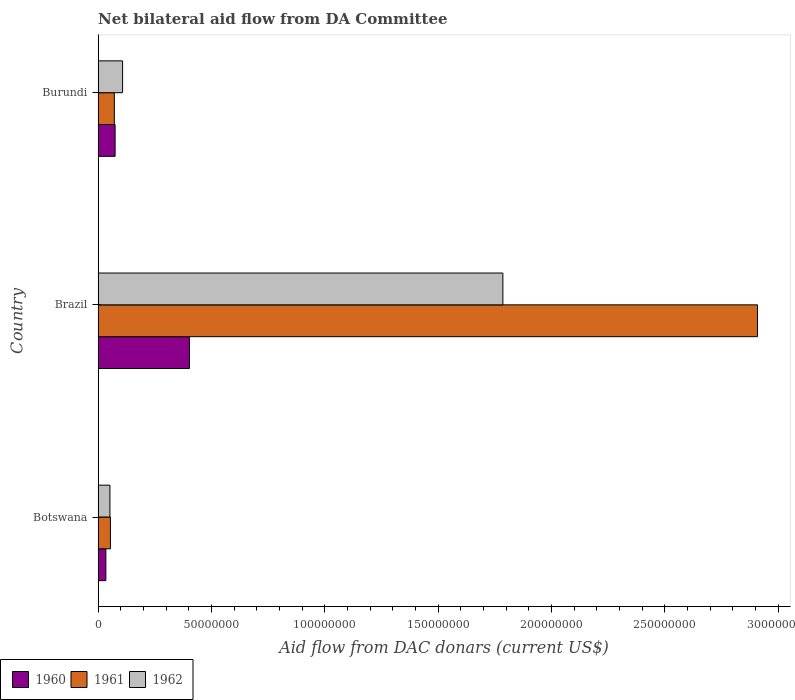Are the number of bars per tick equal to the number of legend labels?
Offer a very short reply. Yes. What is the label of the 3rd group of bars from the top?
Your answer should be very brief. Botswana. What is the aid flow in in 1962 in Burundi?
Keep it short and to the point. 1.08e+07. Across all countries, what is the maximum aid flow in in 1962?
Your answer should be very brief. 1.79e+08. Across all countries, what is the minimum aid flow in in 1961?
Keep it short and to the point. 5.44e+06. In which country was the aid flow in in 1962 minimum?
Offer a very short reply. Botswana. What is the total aid flow in in 1960 in the graph?
Offer a terse response. 5.12e+07. What is the difference between the aid flow in in 1961 in Botswana and that in Brazil?
Offer a terse response. -2.85e+08. What is the difference between the aid flow in in 1961 in Brazil and the aid flow in in 1960 in Botswana?
Give a very brief answer. 2.87e+08. What is the average aid flow in in 1962 per country?
Provide a succinct answer. 6.49e+07. What is the difference between the aid flow in in 1961 and aid flow in in 1962 in Brazil?
Ensure brevity in your answer.  1.12e+08. In how many countries, is the aid flow in in 1961 greater than 280000000 US$?
Your answer should be compact. 1. What is the ratio of the aid flow in in 1960 in Botswana to that in Burundi?
Offer a very short reply. 0.46. Is the difference between the aid flow in in 1961 in Botswana and Burundi greater than the difference between the aid flow in in 1962 in Botswana and Burundi?
Make the answer very short. Yes. What is the difference between the highest and the second highest aid flow in in 1960?
Keep it short and to the point. 3.28e+07. What is the difference between the highest and the lowest aid flow in in 1961?
Your answer should be compact. 2.85e+08. Is the sum of the aid flow in in 1961 in Botswana and Burundi greater than the maximum aid flow in in 1962 across all countries?
Offer a very short reply. No. What does the 1st bar from the top in Brazil represents?
Offer a terse response. 1962. How many countries are there in the graph?
Provide a succinct answer. 3. Does the graph contain any zero values?
Provide a succinct answer. No. What is the title of the graph?
Ensure brevity in your answer.  Net bilateral aid flow from DA Committee. Does "2002" appear as one of the legend labels in the graph?
Ensure brevity in your answer.  No. What is the label or title of the X-axis?
Your response must be concise. Aid flow from DAC donars (current US$). What is the Aid flow from DAC donars (current US$) in 1960 in Botswana?
Ensure brevity in your answer.  3.43e+06. What is the Aid flow from DAC donars (current US$) of 1961 in Botswana?
Your response must be concise. 5.44e+06. What is the Aid flow from DAC donars (current US$) of 1962 in Botswana?
Keep it short and to the point. 5.23e+06. What is the Aid flow from DAC donars (current US$) of 1960 in Brazil?
Provide a succinct answer. 4.03e+07. What is the Aid flow from DAC donars (current US$) in 1961 in Brazil?
Your answer should be very brief. 2.91e+08. What is the Aid flow from DAC donars (current US$) of 1962 in Brazil?
Your answer should be compact. 1.79e+08. What is the Aid flow from DAC donars (current US$) in 1960 in Burundi?
Offer a terse response. 7.51e+06. What is the Aid flow from DAC donars (current US$) in 1961 in Burundi?
Ensure brevity in your answer.  7.17e+06. What is the Aid flow from DAC donars (current US$) in 1962 in Burundi?
Your answer should be very brief. 1.08e+07. Across all countries, what is the maximum Aid flow from DAC donars (current US$) in 1960?
Give a very brief answer. 4.03e+07. Across all countries, what is the maximum Aid flow from DAC donars (current US$) in 1961?
Make the answer very short. 2.91e+08. Across all countries, what is the maximum Aid flow from DAC donars (current US$) of 1962?
Ensure brevity in your answer.  1.79e+08. Across all countries, what is the minimum Aid flow from DAC donars (current US$) of 1960?
Ensure brevity in your answer.  3.43e+06. Across all countries, what is the minimum Aid flow from DAC donars (current US$) in 1961?
Offer a very short reply. 5.44e+06. Across all countries, what is the minimum Aid flow from DAC donars (current US$) of 1962?
Offer a very short reply. 5.23e+06. What is the total Aid flow from DAC donars (current US$) in 1960 in the graph?
Your answer should be compact. 5.12e+07. What is the total Aid flow from DAC donars (current US$) in 1961 in the graph?
Offer a very short reply. 3.04e+08. What is the total Aid flow from DAC donars (current US$) of 1962 in the graph?
Keep it short and to the point. 1.95e+08. What is the difference between the Aid flow from DAC donars (current US$) of 1960 in Botswana and that in Brazil?
Offer a very short reply. -3.69e+07. What is the difference between the Aid flow from DAC donars (current US$) of 1961 in Botswana and that in Brazil?
Give a very brief answer. -2.85e+08. What is the difference between the Aid flow from DAC donars (current US$) in 1962 in Botswana and that in Brazil?
Your response must be concise. -1.73e+08. What is the difference between the Aid flow from DAC donars (current US$) in 1960 in Botswana and that in Burundi?
Offer a very short reply. -4.08e+06. What is the difference between the Aid flow from DAC donars (current US$) of 1961 in Botswana and that in Burundi?
Ensure brevity in your answer.  -1.73e+06. What is the difference between the Aid flow from DAC donars (current US$) of 1962 in Botswana and that in Burundi?
Offer a very short reply. -5.58e+06. What is the difference between the Aid flow from DAC donars (current US$) of 1960 in Brazil and that in Burundi?
Your answer should be compact. 3.28e+07. What is the difference between the Aid flow from DAC donars (current US$) of 1961 in Brazil and that in Burundi?
Your answer should be compact. 2.84e+08. What is the difference between the Aid flow from DAC donars (current US$) in 1962 in Brazil and that in Burundi?
Provide a succinct answer. 1.68e+08. What is the difference between the Aid flow from DAC donars (current US$) in 1960 in Botswana and the Aid flow from DAC donars (current US$) in 1961 in Brazil?
Ensure brevity in your answer.  -2.87e+08. What is the difference between the Aid flow from DAC donars (current US$) in 1960 in Botswana and the Aid flow from DAC donars (current US$) in 1962 in Brazil?
Your answer should be very brief. -1.75e+08. What is the difference between the Aid flow from DAC donars (current US$) in 1961 in Botswana and the Aid flow from DAC donars (current US$) in 1962 in Brazil?
Give a very brief answer. -1.73e+08. What is the difference between the Aid flow from DAC donars (current US$) in 1960 in Botswana and the Aid flow from DAC donars (current US$) in 1961 in Burundi?
Keep it short and to the point. -3.74e+06. What is the difference between the Aid flow from DAC donars (current US$) in 1960 in Botswana and the Aid flow from DAC donars (current US$) in 1962 in Burundi?
Offer a very short reply. -7.38e+06. What is the difference between the Aid flow from DAC donars (current US$) of 1961 in Botswana and the Aid flow from DAC donars (current US$) of 1962 in Burundi?
Offer a terse response. -5.37e+06. What is the difference between the Aid flow from DAC donars (current US$) of 1960 in Brazil and the Aid flow from DAC donars (current US$) of 1961 in Burundi?
Give a very brief answer. 3.31e+07. What is the difference between the Aid flow from DAC donars (current US$) of 1960 in Brazil and the Aid flow from DAC donars (current US$) of 1962 in Burundi?
Your answer should be compact. 2.95e+07. What is the difference between the Aid flow from DAC donars (current US$) of 1961 in Brazil and the Aid flow from DAC donars (current US$) of 1962 in Burundi?
Your answer should be very brief. 2.80e+08. What is the average Aid flow from DAC donars (current US$) in 1960 per country?
Provide a succinct answer. 1.71e+07. What is the average Aid flow from DAC donars (current US$) in 1961 per country?
Provide a succinct answer. 1.01e+08. What is the average Aid flow from DAC donars (current US$) in 1962 per country?
Provide a short and direct response. 6.49e+07. What is the difference between the Aid flow from DAC donars (current US$) of 1960 and Aid flow from DAC donars (current US$) of 1961 in Botswana?
Your answer should be compact. -2.01e+06. What is the difference between the Aid flow from DAC donars (current US$) of 1960 and Aid flow from DAC donars (current US$) of 1962 in Botswana?
Offer a very short reply. -1.80e+06. What is the difference between the Aid flow from DAC donars (current US$) in 1960 and Aid flow from DAC donars (current US$) in 1961 in Brazil?
Keep it short and to the point. -2.51e+08. What is the difference between the Aid flow from DAC donars (current US$) of 1960 and Aid flow from DAC donars (current US$) of 1962 in Brazil?
Ensure brevity in your answer.  -1.38e+08. What is the difference between the Aid flow from DAC donars (current US$) of 1961 and Aid flow from DAC donars (current US$) of 1962 in Brazil?
Provide a short and direct response. 1.12e+08. What is the difference between the Aid flow from DAC donars (current US$) in 1960 and Aid flow from DAC donars (current US$) in 1961 in Burundi?
Give a very brief answer. 3.40e+05. What is the difference between the Aid flow from DAC donars (current US$) in 1960 and Aid flow from DAC donars (current US$) in 1962 in Burundi?
Give a very brief answer. -3.30e+06. What is the difference between the Aid flow from DAC donars (current US$) in 1961 and Aid flow from DAC donars (current US$) in 1962 in Burundi?
Give a very brief answer. -3.64e+06. What is the ratio of the Aid flow from DAC donars (current US$) of 1960 in Botswana to that in Brazil?
Provide a short and direct response. 0.09. What is the ratio of the Aid flow from DAC donars (current US$) of 1961 in Botswana to that in Brazil?
Make the answer very short. 0.02. What is the ratio of the Aid flow from DAC donars (current US$) of 1962 in Botswana to that in Brazil?
Your answer should be very brief. 0.03. What is the ratio of the Aid flow from DAC donars (current US$) of 1960 in Botswana to that in Burundi?
Give a very brief answer. 0.46. What is the ratio of the Aid flow from DAC donars (current US$) of 1961 in Botswana to that in Burundi?
Provide a succinct answer. 0.76. What is the ratio of the Aid flow from DAC donars (current US$) in 1962 in Botswana to that in Burundi?
Keep it short and to the point. 0.48. What is the ratio of the Aid flow from DAC donars (current US$) of 1960 in Brazil to that in Burundi?
Your answer should be very brief. 5.37. What is the ratio of the Aid flow from DAC donars (current US$) in 1961 in Brazil to that in Burundi?
Keep it short and to the point. 40.57. What is the ratio of the Aid flow from DAC donars (current US$) of 1962 in Brazil to that in Burundi?
Offer a terse response. 16.52. What is the difference between the highest and the second highest Aid flow from DAC donars (current US$) in 1960?
Your answer should be very brief. 3.28e+07. What is the difference between the highest and the second highest Aid flow from DAC donars (current US$) in 1961?
Your answer should be compact. 2.84e+08. What is the difference between the highest and the second highest Aid flow from DAC donars (current US$) in 1962?
Offer a terse response. 1.68e+08. What is the difference between the highest and the lowest Aid flow from DAC donars (current US$) of 1960?
Provide a succinct answer. 3.69e+07. What is the difference between the highest and the lowest Aid flow from DAC donars (current US$) of 1961?
Offer a very short reply. 2.85e+08. What is the difference between the highest and the lowest Aid flow from DAC donars (current US$) in 1962?
Make the answer very short. 1.73e+08. 